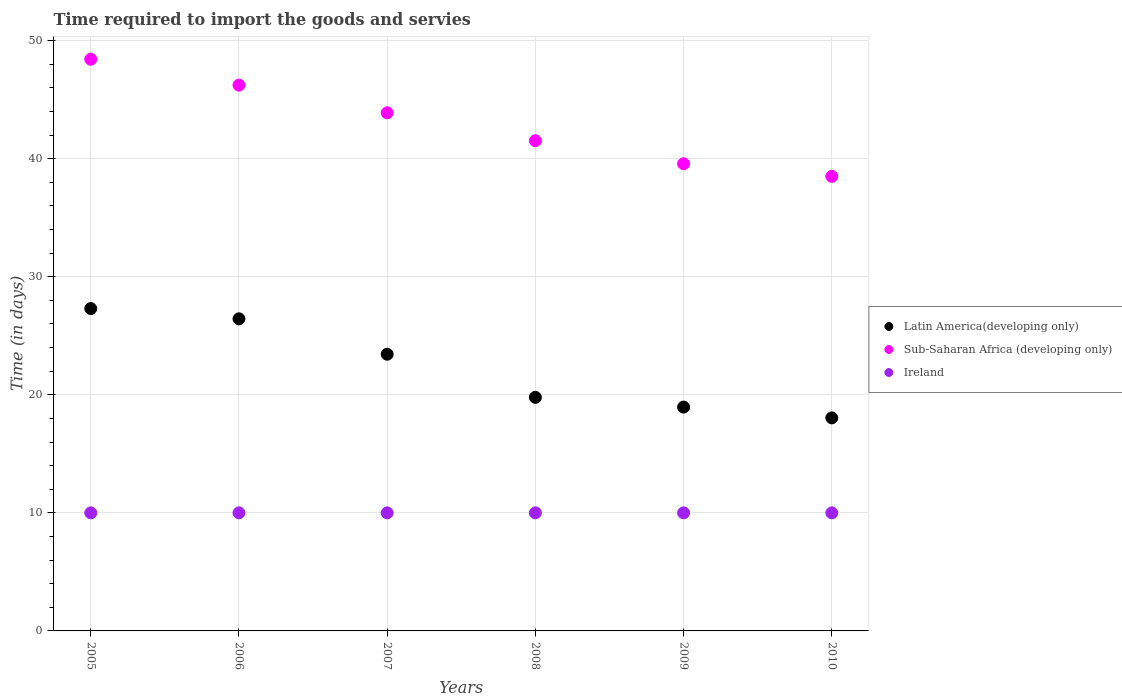Is the number of dotlines equal to the number of legend labels?
Give a very brief answer. Yes. What is the number of days required to import the goods and services in Latin America(developing only) in 2008?
Give a very brief answer. 19.78. Across all years, what is the maximum number of days required to import the goods and services in Ireland?
Offer a terse response. 10. Across all years, what is the minimum number of days required to import the goods and services in Latin America(developing only)?
Offer a terse response. 18.04. In which year was the number of days required to import the goods and services in Latin America(developing only) maximum?
Provide a succinct answer. 2005. In which year was the number of days required to import the goods and services in Latin America(developing only) minimum?
Keep it short and to the point. 2010. What is the total number of days required to import the goods and services in Sub-Saharan Africa (developing only) in the graph?
Offer a terse response. 258.12. What is the difference between the number of days required to import the goods and services in Ireland in 2009 and the number of days required to import the goods and services in Latin America(developing only) in 2010?
Provide a succinct answer. -8.04. What is the average number of days required to import the goods and services in Sub-Saharan Africa (developing only) per year?
Your answer should be compact. 43.02. In the year 2008, what is the difference between the number of days required to import the goods and services in Ireland and number of days required to import the goods and services in Sub-Saharan Africa (developing only)?
Provide a short and direct response. -31.52. In how many years, is the number of days required to import the goods and services in Ireland greater than 26 days?
Provide a short and direct response. 0. What is the ratio of the number of days required to import the goods and services in Latin America(developing only) in 2008 to that in 2009?
Your answer should be very brief. 1.04. What is the difference between the highest and the second highest number of days required to import the goods and services in Ireland?
Your answer should be very brief. 0. What is the difference between the highest and the lowest number of days required to import the goods and services in Latin America(developing only)?
Make the answer very short. 9.26. Is the sum of the number of days required to import the goods and services in Ireland in 2009 and 2010 greater than the maximum number of days required to import the goods and services in Latin America(developing only) across all years?
Provide a succinct answer. No. Does the number of days required to import the goods and services in Ireland monotonically increase over the years?
Ensure brevity in your answer.  No. Is the number of days required to import the goods and services in Sub-Saharan Africa (developing only) strictly greater than the number of days required to import the goods and services in Latin America(developing only) over the years?
Offer a terse response. Yes. What is the difference between two consecutive major ticks on the Y-axis?
Offer a very short reply. 10. Are the values on the major ticks of Y-axis written in scientific E-notation?
Provide a short and direct response. No. Where does the legend appear in the graph?
Your response must be concise. Center right. How many legend labels are there?
Provide a succinct answer. 3. How are the legend labels stacked?
Your answer should be compact. Vertical. What is the title of the graph?
Provide a short and direct response. Time required to import the goods and servies. Does "Bahamas" appear as one of the legend labels in the graph?
Your response must be concise. No. What is the label or title of the X-axis?
Your answer should be compact. Years. What is the label or title of the Y-axis?
Offer a terse response. Time (in days). What is the Time (in days) of Latin America(developing only) in 2005?
Keep it short and to the point. 27.3. What is the Time (in days) in Sub-Saharan Africa (developing only) in 2005?
Offer a terse response. 48.42. What is the Time (in days) in Ireland in 2005?
Your answer should be very brief. 10. What is the Time (in days) in Latin America(developing only) in 2006?
Make the answer very short. 26.43. What is the Time (in days) in Sub-Saharan Africa (developing only) in 2006?
Ensure brevity in your answer.  46.23. What is the Time (in days) in Ireland in 2006?
Make the answer very short. 10. What is the Time (in days) in Latin America(developing only) in 2007?
Your response must be concise. 23.43. What is the Time (in days) in Sub-Saharan Africa (developing only) in 2007?
Provide a short and direct response. 43.89. What is the Time (in days) of Latin America(developing only) in 2008?
Give a very brief answer. 19.78. What is the Time (in days) of Sub-Saharan Africa (developing only) in 2008?
Offer a very short reply. 41.52. What is the Time (in days) of Ireland in 2008?
Ensure brevity in your answer.  10. What is the Time (in days) of Latin America(developing only) in 2009?
Offer a very short reply. 18.96. What is the Time (in days) of Sub-Saharan Africa (developing only) in 2009?
Make the answer very short. 39.57. What is the Time (in days) of Latin America(developing only) in 2010?
Your response must be concise. 18.04. What is the Time (in days) of Sub-Saharan Africa (developing only) in 2010?
Your answer should be very brief. 38.5. What is the Time (in days) in Ireland in 2010?
Make the answer very short. 10. Across all years, what is the maximum Time (in days) in Latin America(developing only)?
Provide a short and direct response. 27.3. Across all years, what is the maximum Time (in days) of Sub-Saharan Africa (developing only)?
Offer a very short reply. 48.42. Across all years, what is the minimum Time (in days) in Latin America(developing only)?
Provide a short and direct response. 18.04. Across all years, what is the minimum Time (in days) of Sub-Saharan Africa (developing only)?
Provide a short and direct response. 38.5. Across all years, what is the minimum Time (in days) of Ireland?
Your answer should be compact. 10. What is the total Time (in days) of Latin America(developing only) in the graph?
Provide a short and direct response. 133.96. What is the total Time (in days) in Sub-Saharan Africa (developing only) in the graph?
Give a very brief answer. 258.12. What is the difference between the Time (in days) of Latin America(developing only) in 2005 and that in 2006?
Provide a succinct answer. 0.87. What is the difference between the Time (in days) of Sub-Saharan Africa (developing only) in 2005 and that in 2006?
Your answer should be compact. 2.19. What is the difference between the Time (in days) of Latin America(developing only) in 2005 and that in 2007?
Make the answer very short. 3.87. What is the difference between the Time (in days) in Sub-Saharan Africa (developing only) in 2005 and that in 2007?
Ensure brevity in your answer.  4.53. What is the difference between the Time (in days) in Ireland in 2005 and that in 2007?
Provide a short and direct response. 0. What is the difference between the Time (in days) of Latin America(developing only) in 2005 and that in 2008?
Keep it short and to the point. 7.52. What is the difference between the Time (in days) in Sub-Saharan Africa (developing only) in 2005 and that in 2008?
Your answer should be very brief. 6.9. What is the difference between the Time (in days) in Ireland in 2005 and that in 2008?
Your answer should be very brief. 0. What is the difference between the Time (in days) of Latin America(developing only) in 2005 and that in 2009?
Your response must be concise. 8.35. What is the difference between the Time (in days) in Sub-Saharan Africa (developing only) in 2005 and that in 2009?
Provide a succinct answer. 8.85. What is the difference between the Time (in days) of Ireland in 2005 and that in 2009?
Provide a succinct answer. 0. What is the difference between the Time (in days) in Latin America(developing only) in 2005 and that in 2010?
Your answer should be compact. 9.26. What is the difference between the Time (in days) in Sub-Saharan Africa (developing only) in 2005 and that in 2010?
Ensure brevity in your answer.  9.92. What is the difference between the Time (in days) in Ireland in 2005 and that in 2010?
Your answer should be very brief. 0. What is the difference between the Time (in days) of Sub-Saharan Africa (developing only) in 2006 and that in 2007?
Your answer should be very brief. 2.34. What is the difference between the Time (in days) of Ireland in 2006 and that in 2007?
Provide a short and direct response. 0. What is the difference between the Time (in days) of Latin America(developing only) in 2006 and that in 2008?
Offer a very short reply. 6.65. What is the difference between the Time (in days) of Sub-Saharan Africa (developing only) in 2006 and that in 2008?
Make the answer very short. 4.7. What is the difference between the Time (in days) in Latin America(developing only) in 2006 and that in 2009?
Offer a very short reply. 7.48. What is the difference between the Time (in days) in Sub-Saharan Africa (developing only) in 2006 and that in 2009?
Your answer should be compact. 6.66. What is the difference between the Time (in days) of Latin America(developing only) in 2006 and that in 2010?
Ensure brevity in your answer.  8.39. What is the difference between the Time (in days) of Sub-Saharan Africa (developing only) in 2006 and that in 2010?
Provide a short and direct response. 7.73. What is the difference between the Time (in days) of Latin America(developing only) in 2007 and that in 2008?
Give a very brief answer. 3.65. What is the difference between the Time (in days) in Sub-Saharan Africa (developing only) in 2007 and that in 2008?
Your answer should be very brief. 2.36. What is the difference between the Time (in days) in Latin America(developing only) in 2007 and that in 2009?
Provide a short and direct response. 4.48. What is the difference between the Time (in days) in Sub-Saharan Africa (developing only) in 2007 and that in 2009?
Provide a succinct answer. 4.32. What is the difference between the Time (in days) in Ireland in 2007 and that in 2009?
Make the answer very short. 0. What is the difference between the Time (in days) of Latin America(developing only) in 2007 and that in 2010?
Give a very brief answer. 5.39. What is the difference between the Time (in days) of Sub-Saharan Africa (developing only) in 2007 and that in 2010?
Keep it short and to the point. 5.39. What is the difference between the Time (in days) in Ireland in 2007 and that in 2010?
Keep it short and to the point. 0. What is the difference between the Time (in days) of Latin America(developing only) in 2008 and that in 2009?
Make the answer very short. 0.83. What is the difference between the Time (in days) in Sub-Saharan Africa (developing only) in 2008 and that in 2009?
Provide a short and direct response. 1.95. What is the difference between the Time (in days) of Latin America(developing only) in 2008 and that in 2010?
Your response must be concise. 1.74. What is the difference between the Time (in days) in Sub-Saharan Africa (developing only) in 2008 and that in 2010?
Your response must be concise. 3.02. What is the difference between the Time (in days) in Ireland in 2008 and that in 2010?
Give a very brief answer. 0. What is the difference between the Time (in days) in Sub-Saharan Africa (developing only) in 2009 and that in 2010?
Give a very brief answer. 1.07. What is the difference between the Time (in days) of Ireland in 2009 and that in 2010?
Your response must be concise. 0. What is the difference between the Time (in days) of Latin America(developing only) in 2005 and the Time (in days) of Sub-Saharan Africa (developing only) in 2006?
Provide a short and direct response. -18.92. What is the difference between the Time (in days) of Latin America(developing only) in 2005 and the Time (in days) of Ireland in 2006?
Your answer should be compact. 17.3. What is the difference between the Time (in days) in Sub-Saharan Africa (developing only) in 2005 and the Time (in days) in Ireland in 2006?
Provide a short and direct response. 38.42. What is the difference between the Time (in days) in Latin America(developing only) in 2005 and the Time (in days) in Sub-Saharan Africa (developing only) in 2007?
Your response must be concise. -16.58. What is the difference between the Time (in days) in Latin America(developing only) in 2005 and the Time (in days) in Ireland in 2007?
Provide a succinct answer. 17.3. What is the difference between the Time (in days) of Sub-Saharan Africa (developing only) in 2005 and the Time (in days) of Ireland in 2007?
Provide a short and direct response. 38.42. What is the difference between the Time (in days) of Latin America(developing only) in 2005 and the Time (in days) of Sub-Saharan Africa (developing only) in 2008?
Your answer should be very brief. -14.22. What is the difference between the Time (in days) of Latin America(developing only) in 2005 and the Time (in days) of Ireland in 2008?
Make the answer very short. 17.3. What is the difference between the Time (in days) of Sub-Saharan Africa (developing only) in 2005 and the Time (in days) of Ireland in 2008?
Your response must be concise. 38.42. What is the difference between the Time (in days) of Latin America(developing only) in 2005 and the Time (in days) of Sub-Saharan Africa (developing only) in 2009?
Offer a very short reply. -12.26. What is the difference between the Time (in days) of Latin America(developing only) in 2005 and the Time (in days) of Ireland in 2009?
Make the answer very short. 17.3. What is the difference between the Time (in days) of Sub-Saharan Africa (developing only) in 2005 and the Time (in days) of Ireland in 2009?
Your answer should be very brief. 38.42. What is the difference between the Time (in days) of Latin America(developing only) in 2005 and the Time (in days) of Sub-Saharan Africa (developing only) in 2010?
Your response must be concise. -11.2. What is the difference between the Time (in days) in Latin America(developing only) in 2005 and the Time (in days) in Ireland in 2010?
Provide a short and direct response. 17.3. What is the difference between the Time (in days) in Sub-Saharan Africa (developing only) in 2005 and the Time (in days) in Ireland in 2010?
Your answer should be very brief. 38.42. What is the difference between the Time (in days) of Latin America(developing only) in 2006 and the Time (in days) of Sub-Saharan Africa (developing only) in 2007?
Your response must be concise. -17.45. What is the difference between the Time (in days) in Latin America(developing only) in 2006 and the Time (in days) in Ireland in 2007?
Give a very brief answer. 16.43. What is the difference between the Time (in days) of Sub-Saharan Africa (developing only) in 2006 and the Time (in days) of Ireland in 2007?
Your answer should be very brief. 36.23. What is the difference between the Time (in days) of Latin America(developing only) in 2006 and the Time (in days) of Sub-Saharan Africa (developing only) in 2008?
Provide a short and direct response. -15.09. What is the difference between the Time (in days) of Latin America(developing only) in 2006 and the Time (in days) of Ireland in 2008?
Offer a terse response. 16.43. What is the difference between the Time (in days) in Sub-Saharan Africa (developing only) in 2006 and the Time (in days) in Ireland in 2008?
Provide a succinct answer. 36.23. What is the difference between the Time (in days) of Latin America(developing only) in 2006 and the Time (in days) of Sub-Saharan Africa (developing only) in 2009?
Make the answer very short. -13.13. What is the difference between the Time (in days) in Latin America(developing only) in 2006 and the Time (in days) in Ireland in 2009?
Offer a very short reply. 16.43. What is the difference between the Time (in days) in Sub-Saharan Africa (developing only) in 2006 and the Time (in days) in Ireland in 2009?
Offer a terse response. 36.23. What is the difference between the Time (in days) in Latin America(developing only) in 2006 and the Time (in days) in Sub-Saharan Africa (developing only) in 2010?
Provide a short and direct response. -12.07. What is the difference between the Time (in days) of Latin America(developing only) in 2006 and the Time (in days) of Ireland in 2010?
Give a very brief answer. 16.43. What is the difference between the Time (in days) of Sub-Saharan Africa (developing only) in 2006 and the Time (in days) of Ireland in 2010?
Your response must be concise. 36.23. What is the difference between the Time (in days) of Latin America(developing only) in 2007 and the Time (in days) of Sub-Saharan Africa (developing only) in 2008?
Give a very brief answer. -18.09. What is the difference between the Time (in days) in Latin America(developing only) in 2007 and the Time (in days) in Ireland in 2008?
Your answer should be compact. 13.43. What is the difference between the Time (in days) in Sub-Saharan Africa (developing only) in 2007 and the Time (in days) in Ireland in 2008?
Make the answer very short. 33.89. What is the difference between the Time (in days) in Latin America(developing only) in 2007 and the Time (in days) in Sub-Saharan Africa (developing only) in 2009?
Your answer should be compact. -16.13. What is the difference between the Time (in days) of Latin America(developing only) in 2007 and the Time (in days) of Ireland in 2009?
Keep it short and to the point. 13.43. What is the difference between the Time (in days) in Sub-Saharan Africa (developing only) in 2007 and the Time (in days) in Ireland in 2009?
Give a very brief answer. 33.89. What is the difference between the Time (in days) in Latin America(developing only) in 2007 and the Time (in days) in Sub-Saharan Africa (developing only) in 2010?
Provide a succinct answer. -15.07. What is the difference between the Time (in days) of Latin America(developing only) in 2007 and the Time (in days) of Ireland in 2010?
Ensure brevity in your answer.  13.43. What is the difference between the Time (in days) in Sub-Saharan Africa (developing only) in 2007 and the Time (in days) in Ireland in 2010?
Your answer should be very brief. 33.89. What is the difference between the Time (in days) in Latin America(developing only) in 2008 and the Time (in days) in Sub-Saharan Africa (developing only) in 2009?
Offer a very short reply. -19.79. What is the difference between the Time (in days) in Latin America(developing only) in 2008 and the Time (in days) in Ireland in 2009?
Ensure brevity in your answer.  9.78. What is the difference between the Time (in days) of Sub-Saharan Africa (developing only) in 2008 and the Time (in days) of Ireland in 2009?
Provide a succinct answer. 31.52. What is the difference between the Time (in days) in Latin America(developing only) in 2008 and the Time (in days) in Sub-Saharan Africa (developing only) in 2010?
Offer a terse response. -18.72. What is the difference between the Time (in days) in Latin America(developing only) in 2008 and the Time (in days) in Ireland in 2010?
Provide a succinct answer. 9.78. What is the difference between the Time (in days) in Sub-Saharan Africa (developing only) in 2008 and the Time (in days) in Ireland in 2010?
Offer a very short reply. 31.52. What is the difference between the Time (in days) of Latin America(developing only) in 2009 and the Time (in days) of Sub-Saharan Africa (developing only) in 2010?
Your response must be concise. -19.54. What is the difference between the Time (in days) in Latin America(developing only) in 2009 and the Time (in days) in Ireland in 2010?
Your answer should be compact. 8.96. What is the difference between the Time (in days) in Sub-Saharan Africa (developing only) in 2009 and the Time (in days) in Ireland in 2010?
Your answer should be very brief. 29.57. What is the average Time (in days) in Latin America(developing only) per year?
Offer a terse response. 22.33. What is the average Time (in days) of Sub-Saharan Africa (developing only) per year?
Give a very brief answer. 43.02. In the year 2005, what is the difference between the Time (in days) of Latin America(developing only) and Time (in days) of Sub-Saharan Africa (developing only)?
Offer a terse response. -21.11. In the year 2005, what is the difference between the Time (in days) in Latin America(developing only) and Time (in days) in Ireland?
Provide a short and direct response. 17.3. In the year 2005, what is the difference between the Time (in days) in Sub-Saharan Africa (developing only) and Time (in days) in Ireland?
Keep it short and to the point. 38.42. In the year 2006, what is the difference between the Time (in days) in Latin America(developing only) and Time (in days) in Sub-Saharan Africa (developing only)?
Your answer should be compact. -19.79. In the year 2006, what is the difference between the Time (in days) of Latin America(developing only) and Time (in days) of Ireland?
Keep it short and to the point. 16.43. In the year 2006, what is the difference between the Time (in days) in Sub-Saharan Africa (developing only) and Time (in days) in Ireland?
Provide a short and direct response. 36.23. In the year 2007, what is the difference between the Time (in days) in Latin America(developing only) and Time (in days) in Sub-Saharan Africa (developing only)?
Provide a succinct answer. -20.45. In the year 2007, what is the difference between the Time (in days) of Latin America(developing only) and Time (in days) of Ireland?
Provide a succinct answer. 13.43. In the year 2007, what is the difference between the Time (in days) in Sub-Saharan Africa (developing only) and Time (in days) in Ireland?
Offer a terse response. 33.89. In the year 2008, what is the difference between the Time (in days) of Latin America(developing only) and Time (in days) of Sub-Saharan Africa (developing only)?
Your answer should be very brief. -21.74. In the year 2008, what is the difference between the Time (in days) of Latin America(developing only) and Time (in days) of Ireland?
Ensure brevity in your answer.  9.78. In the year 2008, what is the difference between the Time (in days) in Sub-Saharan Africa (developing only) and Time (in days) in Ireland?
Offer a terse response. 31.52. In the year 2009, what is the difference between the Time (in days) of Latin America(developing only) and Time (in days) of Sub-Saharan Africa (developing only)?
Give a very brief answer. -20.61. In the year 2009, what is the difference between the Time (in days) of Latin America(developing only) and Time (in days) of Ireland?
Offer a very short reply. 8.96. In the year 2009, what is the difference between the Time (in days) of Sub-Saharan Africa (developing only) and Time (in days) of Ireland?
Offer a very short reply. 29.57. In the year 2010, what is the difference between the Time (in days) of Latin America(developing only) and Time (in days) of Sub-Saharan Africa (developing only)?
Your response must be concise. -20.46. In the year 2010, what is the difference between the Time (in days) of Latin America(developing only) and Time (in days) of Ireland?
Give a very brief answer. 8.04. In the year 2010, what is the difference between the Time (in days) in Sub-Saharan Africa (developing only) and Time (in days) in Ireland?
Provide a succinct answer. 28.5. What is the ratio of the Time (in days) of Latin America(developing only) in 2005 to that in 2006?
Make the answer very short. 1.03. What is the ratio of the Time (in days) of Sub-Saharan Africa (developing only) in 2005 to that in 2006?
Ensure brevity in your answer.  1.05. What is the ratio of the Time (in days) in Ireland in 2005 to that in 2006?
Your answer should be very brief. 1. What is the ratio of the Time (in days) in Latin America(developing only) in 2005 to that in 2007?
Ensure brevity in your answer.  1.17. What is the ratio of the Time (in days) of Sub-Saharan Africa (developing only) in 2005 to that in 2007?
Keep it short and to the point. 1.1. What is the ratio of the Time (in days) of Latin America(developing only) in 2005 to that in 2008?
Ensure brevity in your answer.  1.38. What is the ratio of the Time (in days) of Sub-Saharan Africa (developing only) in 2005 to that in 2008?
Provide a succinct answer. 1.17. What is the ratio of the Time (in days) of Latin America(developing only) in 2005 to that in 2009?
Keep it short and to the point. 1.44. What is the ratio of the Time (in days) in Sub-Saharan Africa (developing only) in 2005 to that in 2009?
Your response must be concise. 1.22. What is the ratio of the Time (in days) in Latin America(developing only) in 2005 to that in 2010?
Provide a short and direct response. 1.51. What is the ratio of the Time (in days) of Sub-Saharan Africa (developing only) in 2005 to that in 2010?
Keep it short and to the point. 1.26. What is the ratio of the Time (in days) in Ireland in 2005 to that in 2010?
Keep it short and to the point. 1. What is the ratio of the Time (in days) of Latin America(developing only) in 2006 to that in 2007?
Provide a succinct answer. 1.13. What is the ratio of the Time (in days) of Sub-Saharan Africa (developing only) in 2006 to that in 2007?
Your answer should be compact. 1.05. What is the ratio of the Time (in days) in Ireland in 2006 to that in 2007?
Your answer should be very brief. 1. What is the ratio of the Time (in days) of Latin America(developing only) in 2006 to that in 2008?
Your response must be concise. 1.34. What is the ratio of the Time (in days) in Sub-Saharan Africa (developing only) in 2006 to that in 2008?
Give a very brief answer. 1.11. What is the ratio of the Time (in days) of Latin America(developing only) in 2006 to that in 2009?
Provide a succinct answer. 1.39. What is the ratio of the Time (in days) in Sub-Saharan Africa (developing only) in 2006 to that in 2009?
Provide a short and direct response. 1.17. What is the ratio of the Time (in days) in Ireland in 2006 to that in 2009?
Give a very brief answer. 1. What is the ratio of the Time (in days) of Latin America(developing only) in 2006 to that in 2010?
Ensure brevity in your answer.  1.47. What is the ratio of the Time (in days) in Sub-Saharan Africa (developing only) in 2006 to that in 2010?
Your answer should be compact. 1.2. What is the ratio of the Time (in days) of Ireland in 2006 to that in 2010?
Your response must be concise. 1. What is the ratio of the Time (in days) of Latin America(developing only) in 2007 to that in 2008?
Your response must be concise. 1.18. What is the ratio of the Time (in days) in Sub-Saharan Africa (developing only) in 2007 to that in 2008?
Your response must be concise. 1.06. What is the ratio of the Time (in days) in Latin America(developing only) in 2007 to that in 2009?
Provide a succinct answer. 1.24. What is the ratio of the Time (in days) of Sub-Saharan Africa (developing only) in 2007 to that in 2009?
Your response must be concise. 1.11. What is the ratio of the Time (in days) of Ireland in 2007 to that in 2009?
Give a very brief answer. 1. What is the ratio of the Time (in days) of Latin America(developing only) in 2007 to that in 2010?
Your response must be concise. 1.3. What is the ratio of the Time (in days) of Sub-Saharan Africa (developing only) in 2007 to that in 2010?
Your response must be concise. 1.14. What is the ratio of the Time (in days) in Ireland in 2007 to that in 2010?
Your response must be concise. 1. What is the ratio of the Time (in days) in Latin America(developing only) in 2008 to that in 2009?
Offer a terse response. 1.04. What is the ratio of the Time (in days) in Sub-Saharan Africa (developing only) in 2008 to that in 2009?
Offer a terse response. 1.05. What is the ratio of the Time (in days) of Ireland in 2008 to that in 2009?
Your answer should be compact. 1. What is the ratio of the Time (in days) in Latin America(developing only) in 2008 to that in 2010?
Make the answer very short. 1.1. What is the ratio of the Time (in days) in Sub-Saharan Africa (developing only) in 2008 to that in 2010?
Offer a terse response. 1.08. What is the ratio of the Time (in days) of Ireland in 2008 to that in 2010?
Provide a short and direct response. 1. What is the ratio of the Time (in days) in Latin America(developing only) in 2009 to that in 2010?
Provide a succinct answer. 1.05. What is the ratio of the Time (in days) of Sub-Saharan Africa (developing only) in 2009 to that in 2010?
Give a very brief answer. 1.03. What is the difference between the highest and the second highest Time (in days) in Latin America(developing only)?
Ensure brevity in your answer.  0.87. What is the difference between the highest and the second highest Time (in days) in Sub-Saharan Africa (developing only)?
Ensure brevity in your answer.  2.19. What is the difference between the highest and the lowest Time (in days) of Latin America(developing only)?
Your answer should be compact. 9.26. What is the difference between the highest and the lowest Time (in days) in Sub-Saharan Africa (developing only)?
Offer a terse response. 9.92. What is the difference between the highest and the lowest Time (in days) in Ireland?
Your response must be concise. 0. 